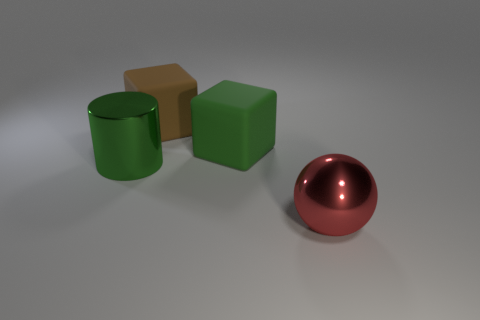Add 2 tiny purple things. How many objects exist? 6 Subtract all balls. How many objects are left? 3 Add 4 green metal cylinders. How many green metal cylinders are left? 5 Add 1 tiny cyan spheres. How many tiny cyan spheres exist? 1 Subtract 0 brown balls. How many objects are left? 4 Subtract all purple cubes. Subtract all purple cylinders. How many cubes are left? 2 Subtract all green metallic things. Subtract all brown rubber spheres. How many objects are left? 3 